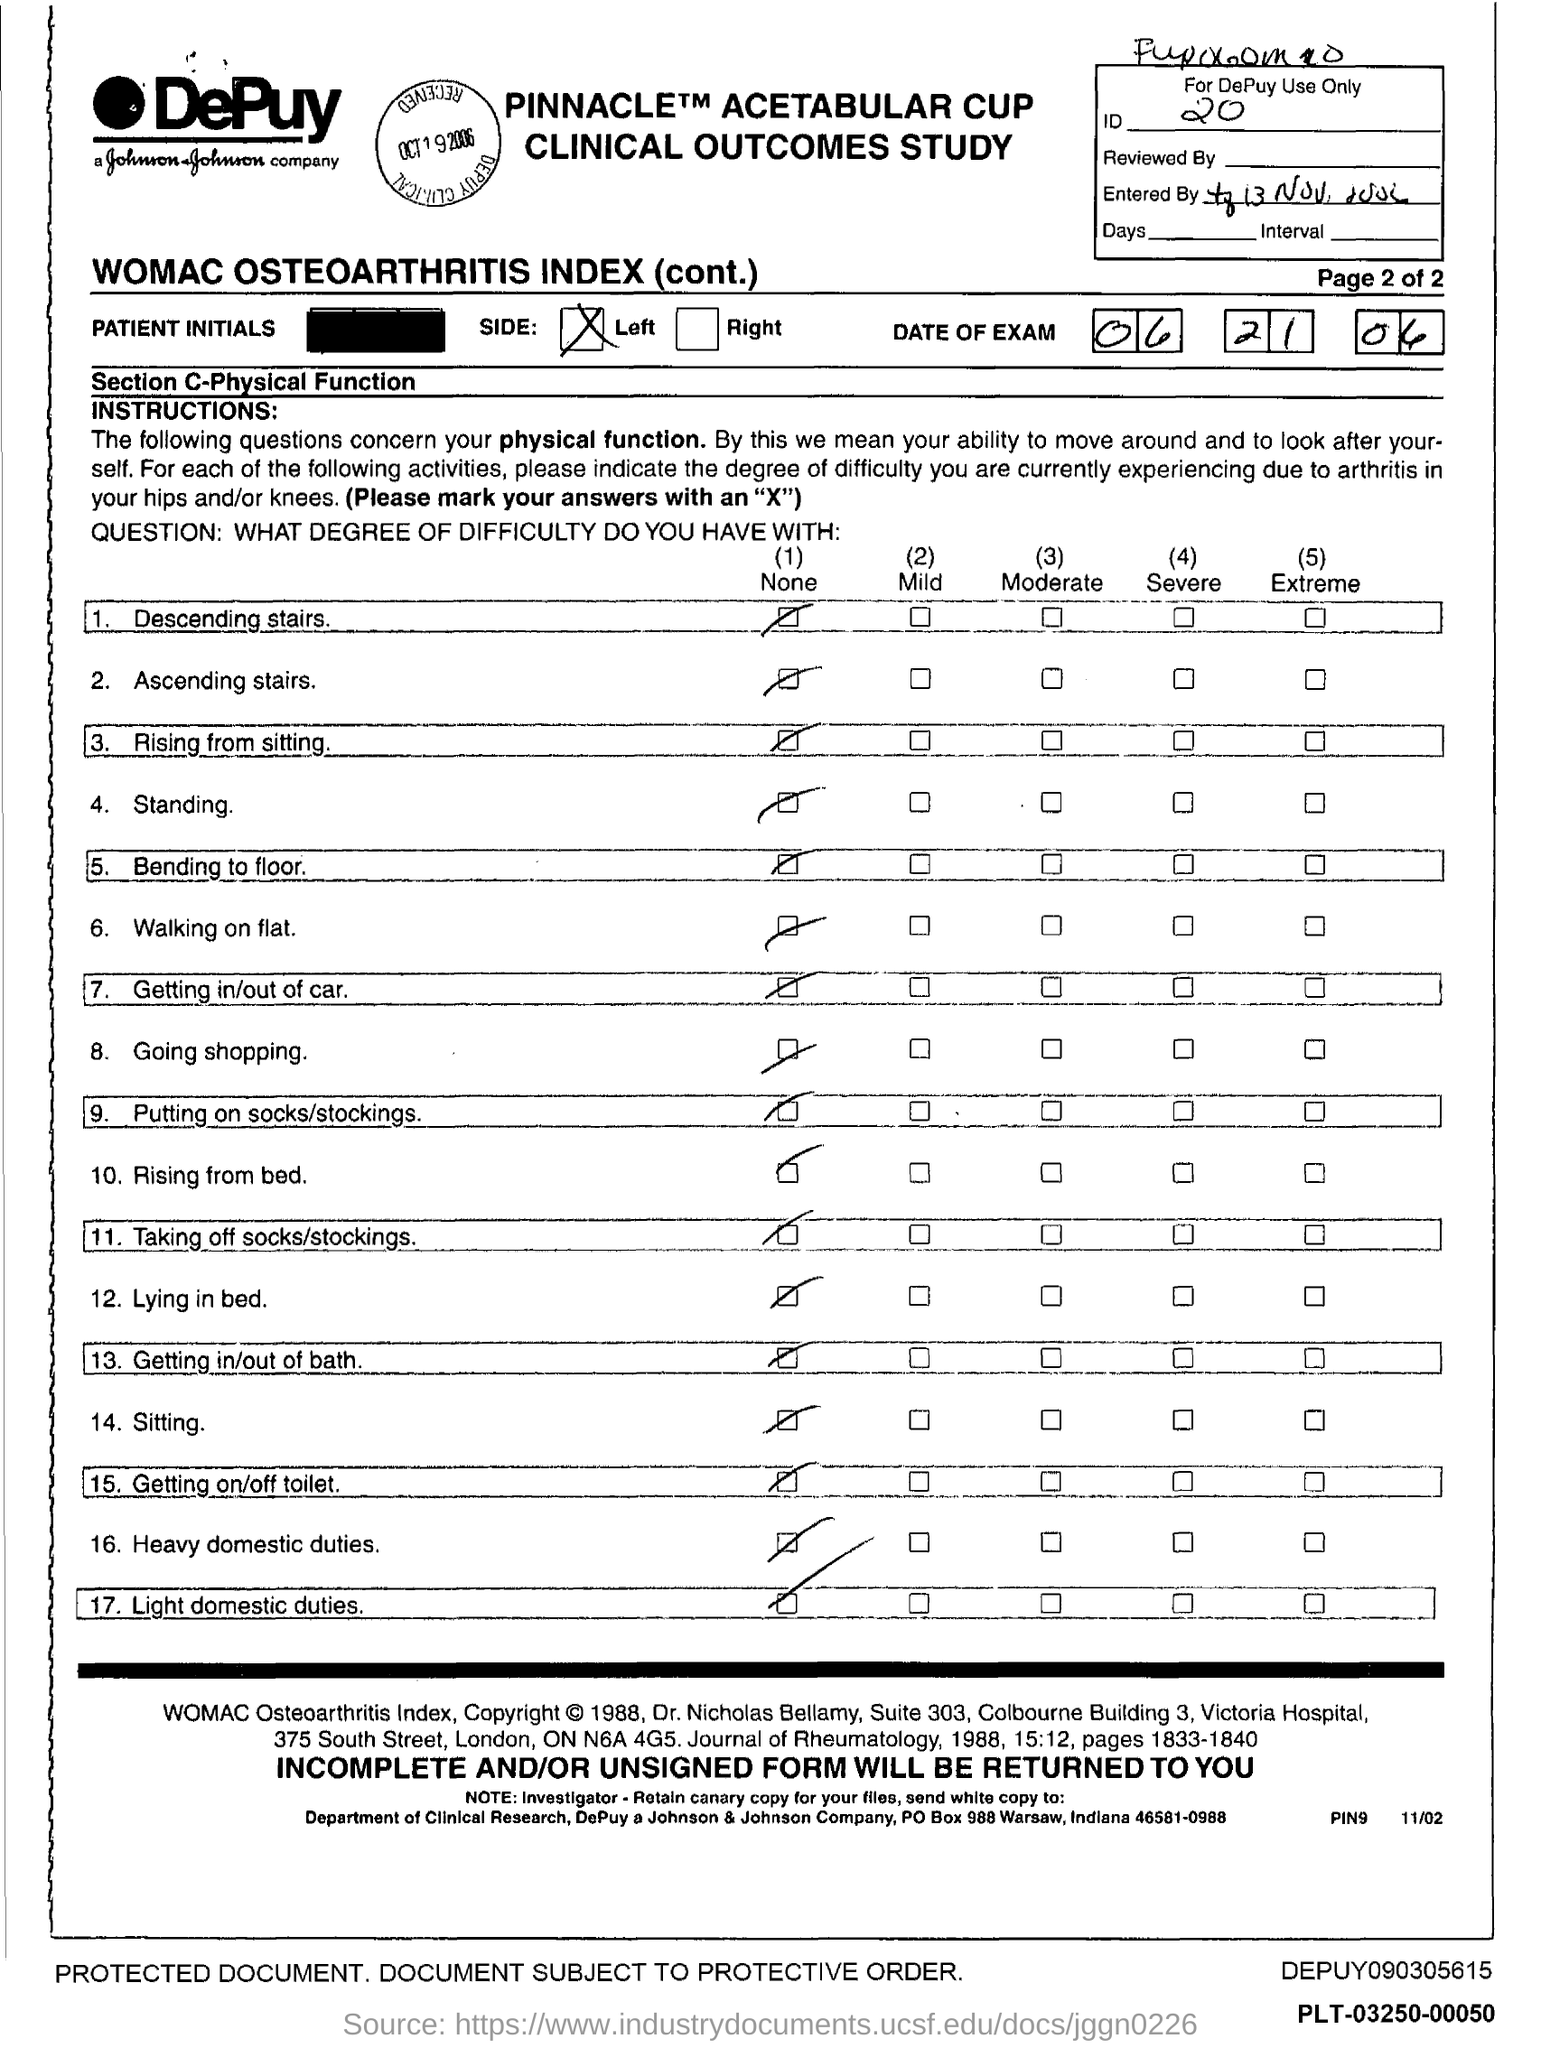What is the id no.?
Your response must be concise. 20. What is the po box no. johnson & johnson company ?
Offer a terse response. 988. In which state is johnson & johnson company at?
Give a very brief answer. Indiana. 